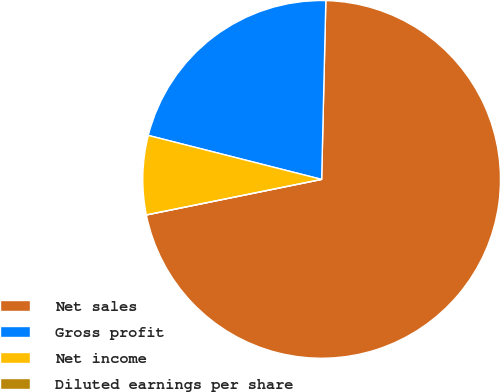Convert chart. <chart><loc_0><loc_0><loc_500><loc_500><pie_chart><fcel>Net sales<fcel>Gross profit<fcel>Net income<fcel>Diluted earnings per share<nl><fcel>71.44%<fcel>21.42%<fcel>7.14%<fcel>0.0%<nl></chart> 